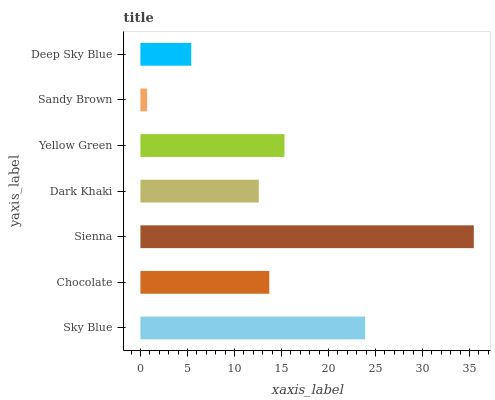Is Sandy Brown the minimum?
Answer yes or no. Yes. Is Sienna the maximum?
Answer yes or no. Yes. Is Chocolate the minimum?
Answer yes or no. No. Is Chocolate the maximum?
Answer yes or no. No. Is Sky Blue greater than Chocolate?
Answer yes or no. Yes. Is Chocolate less than Sky Blue?
Answer yes or no. Yes. Is Chocolate greater than Sky Blue?
Answer yes or no. No. Is Sky Blue less than Chocolate?
Answer yes or no. No. Is Chocolate the high median?
Answer yes or no. Yes. Is Chocolate the low median?
Answer yes or no. Yes. Is Sienna the high median?
Answer yes or no. No. Is Sienna the low median?
Answer yes or no. No. 